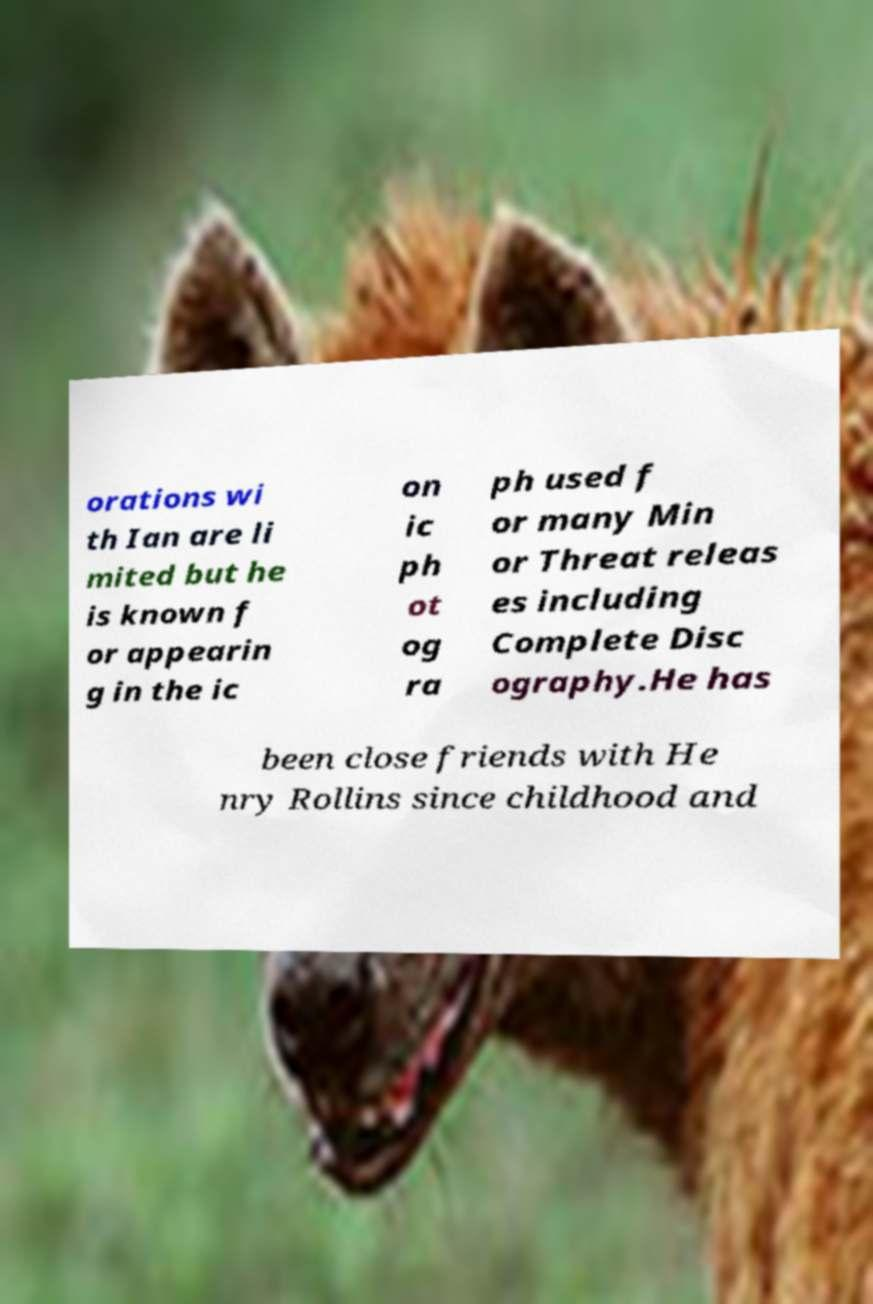Please identify and transcribe the text found in this image. orations wi th Ian are li mited but he is known f or appearin g in the ic on ic ph ot og ra ph used f or many Min or Threat releas es including Complete Disc ography.He has been close friends with He nry Rollins since childhood and 